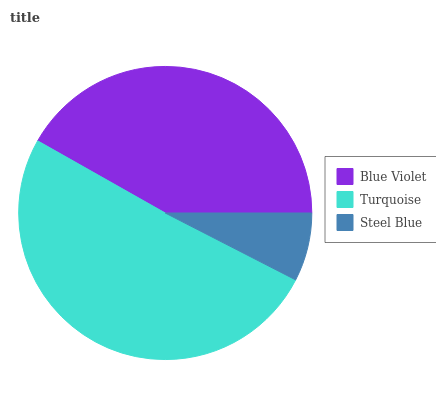Is Steel Blue the minimum?
Answer yes or no. Yes. Is Turquoise the maximum?
Answer yes or no. Yes. Is Turquoise the minimum?
Answer yes or no. No. Is Steel Blue the maximum?
Answer yes or no. No. Is Turquoise greater than Steel Blue?
Answer yes or no. Yes. Is Steel Blue less than Turquoise?
Answer yes or no. Yes. Is Steel Blue greater than Turquoise?
Answer yes or no. No. Is Turquoise less than Steel Blue?
Answer yes or no. No. Is Blue Violet the high median?
Answer yes or no. Yes. Is Blue Violet the low median?
Answer yes or no. Yes. Is Steel Blue the high median?
Answer yes or no. No. Is Steel Blue the low median?
Answer yes or no. No. 